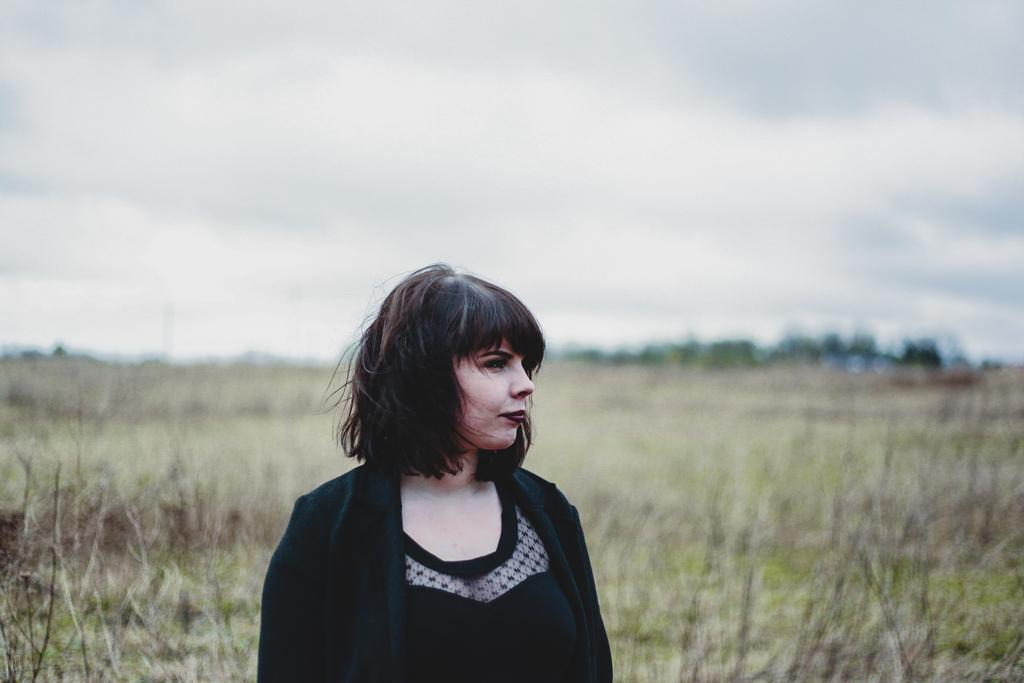What is the main subject of the image? There is a person standing in the center of the image. What is the person wearing in the image? The person is wearing a different costume. Can you describe the background of the image? The background of the image is blurred. What type of transport can be seen in the background of the image? There is no transport visible in the background of the image; it is blurred. How does the person's costume compare to the camp attire in the image? There is no camp or camp attire present in the image. 